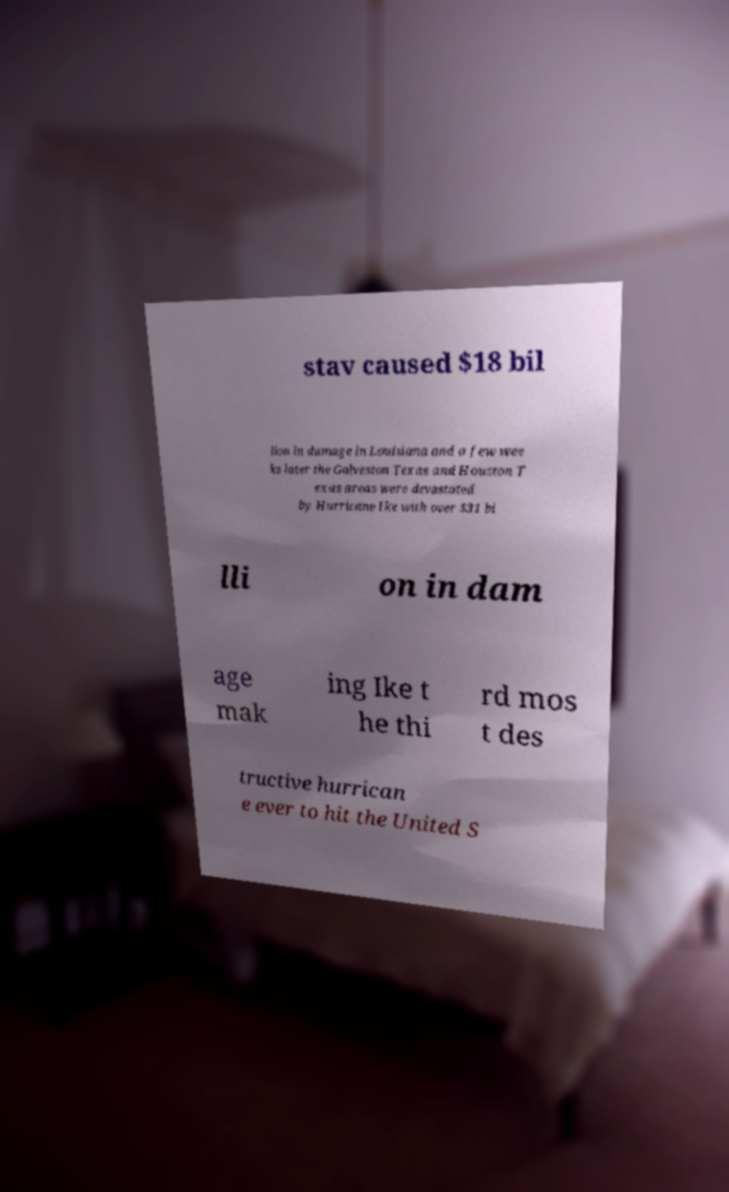What messages or text are displayed in this image? I need them in a readable, typed format. stav caused $18 bil lion in damage in Louisiana and a few wee ks later the Galveston Texas and Houston T exas areas were devastated by Hurricane Ike with over $31 bi lli on in dam age mak ing Ike t he thi rd mos t des tructive hurrican e ever to hit the United S 